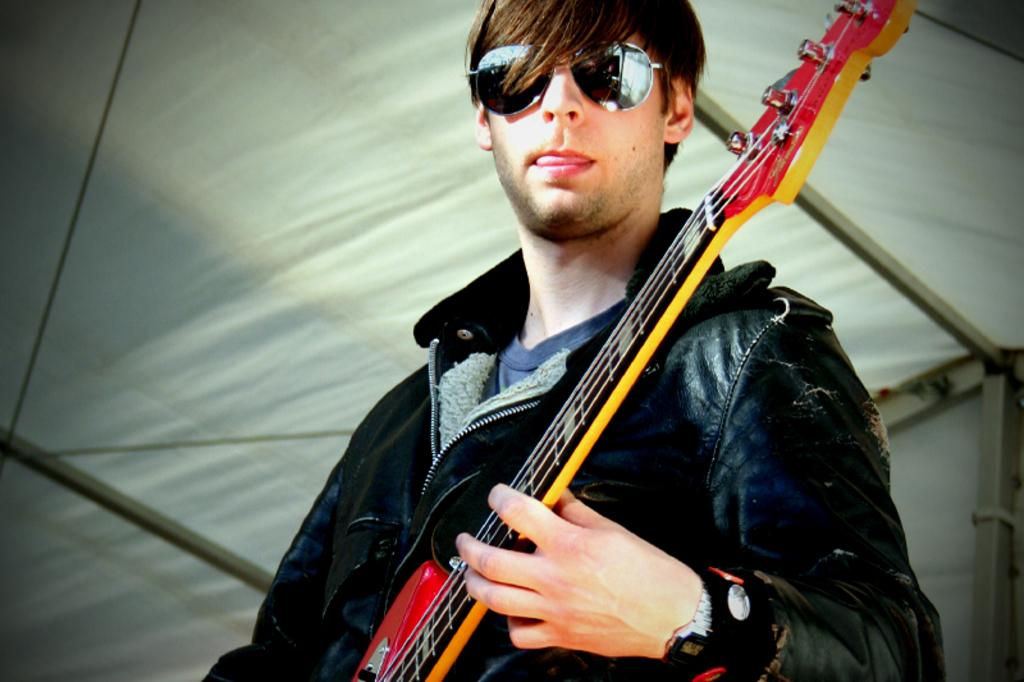What is the main subject of the image? There is a man in the image. What is the man doing in the image? The man is standing and playing a guitar. What accessory is the man wearing in the image? The man is wearing sunglasses. Can you hear the man sneezing in the image? There is no sound in the image, so it is not possible to hear the man sneezing. 